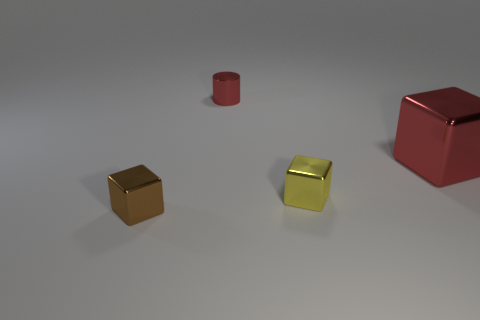Subtract all brown cubes. How many cubes are left? 2 Add 1 small yellow metal things. How many objects exist? 5 Subtract all yellow cubes. How many cubes are left? 2 Subtract all cylinders. How many objects are left? 3 Subtract 2 blocks. How many blocks are left? 1 Subtract all green cubes. Subtract all red cylinders. How many cubes are left? 3 Subtract 0 gray cubes. How many objects are left? 4 Subtract all gray spheres. How many red blocks are left? 1 Subtract all red cylinders. Subtract all tiny red metallic objects. How many objects are left? 2 Add 4 tiny cylinders. How many tiny cylinders are left? 5 